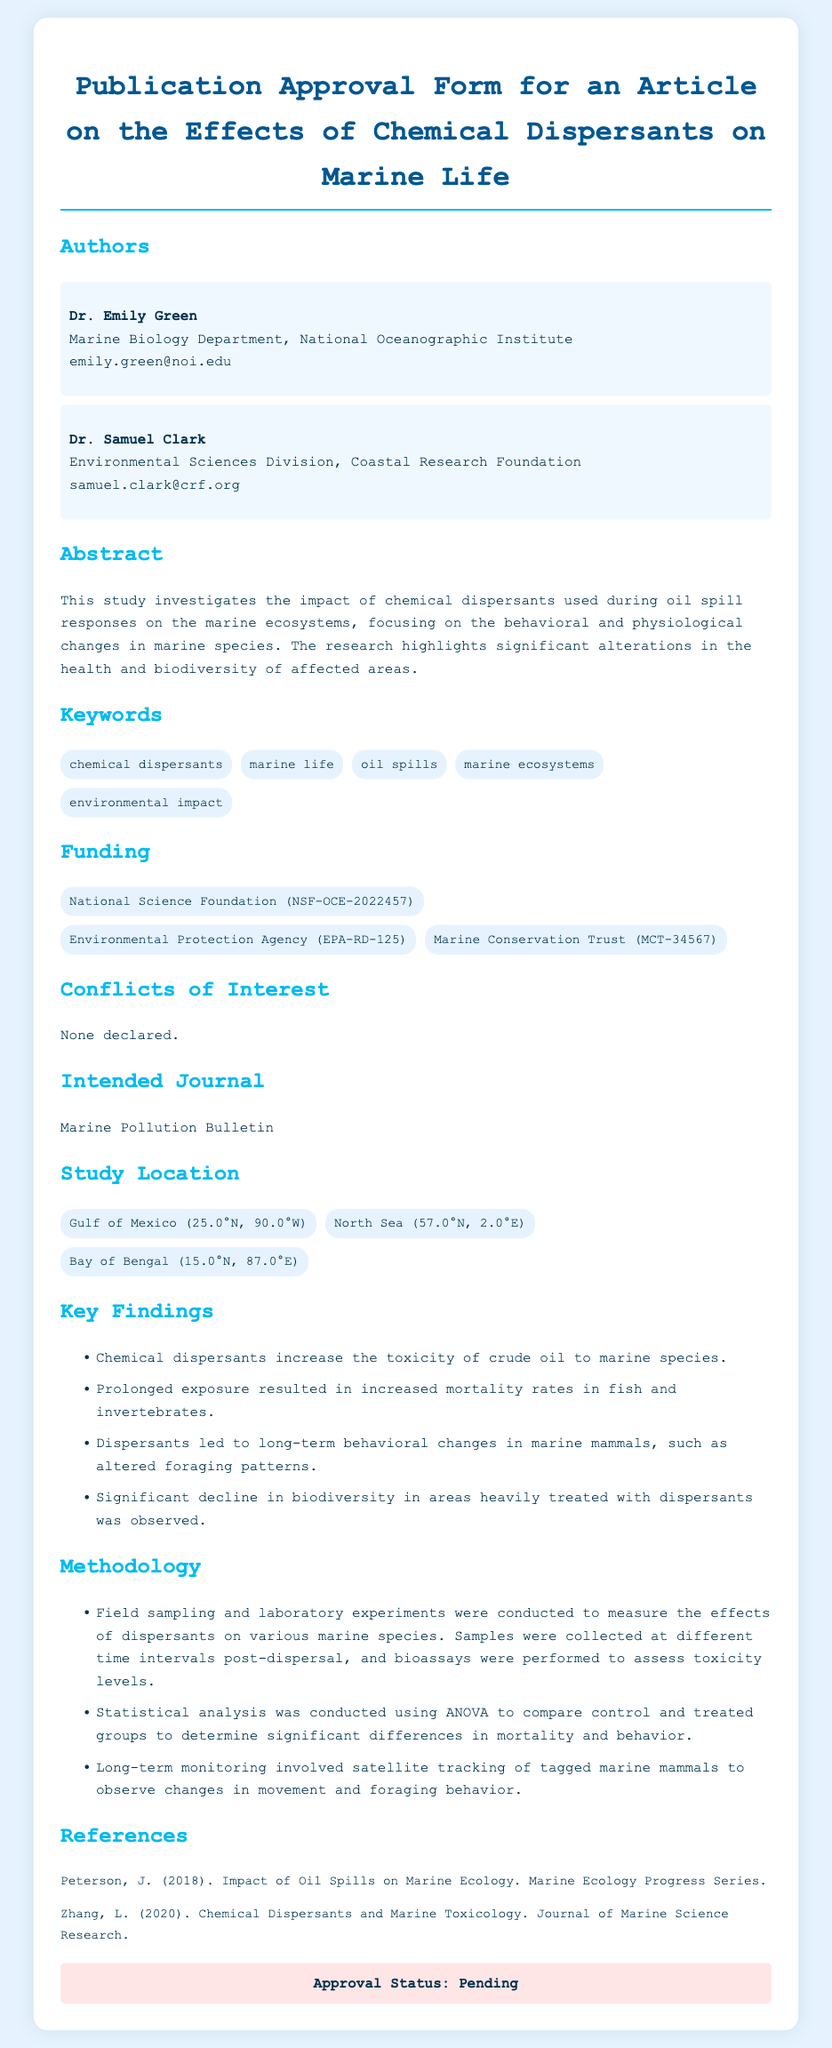What is the title of the article? The title is present in the header section of the document, which highlights the main topic of the publication.
Answer: Publication Approval Form for an Article on the Effects of Chemical Dispersants on Marine Life Who is the first author? The first author's name is listed in the authors section, highlighting the main contributor to the research.
Answer: Dr. Emily Green What is the intended journal for publication? The intended journal is stated in a specific section of the document where authors denote where they wish to submit their work.
Answer: Marine Pollution Bulletin How many keywords are listed in the document? The number of keywords can be counted from the keywords section, showcasing the topics related to the research.
Answer: 5 What significant finding involves marine mammals? This finding is mentioned in the key findings section, emphasizing the impact on marine mammals and their behavior.
Answer: Dispersants led to long-term behavioral changes in marine mammals, such as altered foraging patterns Which funding organization is mentioned first? The funding organizations are listed in a specific section, highlighting those that financially supported the research.
Answer: National Science Foundation (NSF-OCE-2022457) What statistical method was used in the methodology? The statistical method is indicated in the methodology section, detailing how the results were analyzed.
Answer: ANOVA Is there a declared conflict of interest? This section is specifically designated to address any potential conflicts that could bias the research.
Answer: None declared 